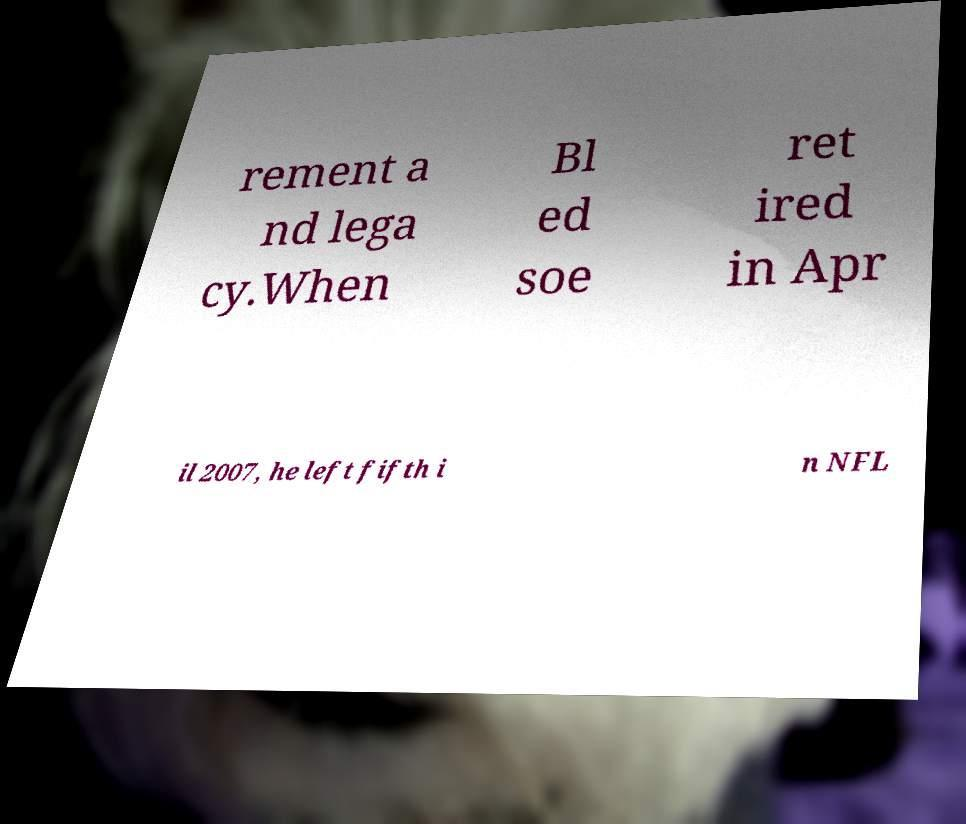Can you read and provide the text displayed in the image?This photo seems to have some interesting text. Can you extract and type it out for me? rement a nd lega cy.When Bl ed soe ret ired in Apr il 2007, he left fifth i n NFL 